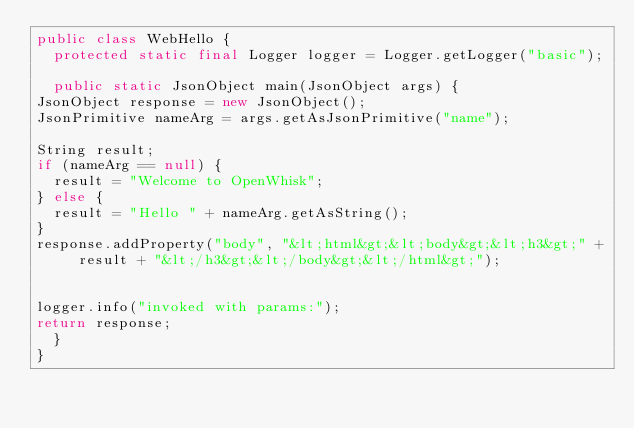Convert code to text. <code><loc_0><loc_0><loc_500><loc_500><_Java_>public class WebHello {
  protected static final Logger logger = Logger.getLogger("basic");

  public static JsonObject main(JsonObject args) {
JsonObject response = new JsonObject();
JsonPrimitive nameArg = args.getAsJsonPrimitive("name");

String result;
if (nameArg == null) {
  result = "Welcome to OpenWhisk";
} else {
  result = "Hello " + nameArg.getAsString();
}
response.addProperty("body", "&lt;html&gt;&lt;body&gt;&lt;h3&gt;" + result + "&lt;/h3&gt;&lt;/body&gt;&lt;/html&gt;");


logger.info("invoked with params:");
return response;
  }
}
</code> 